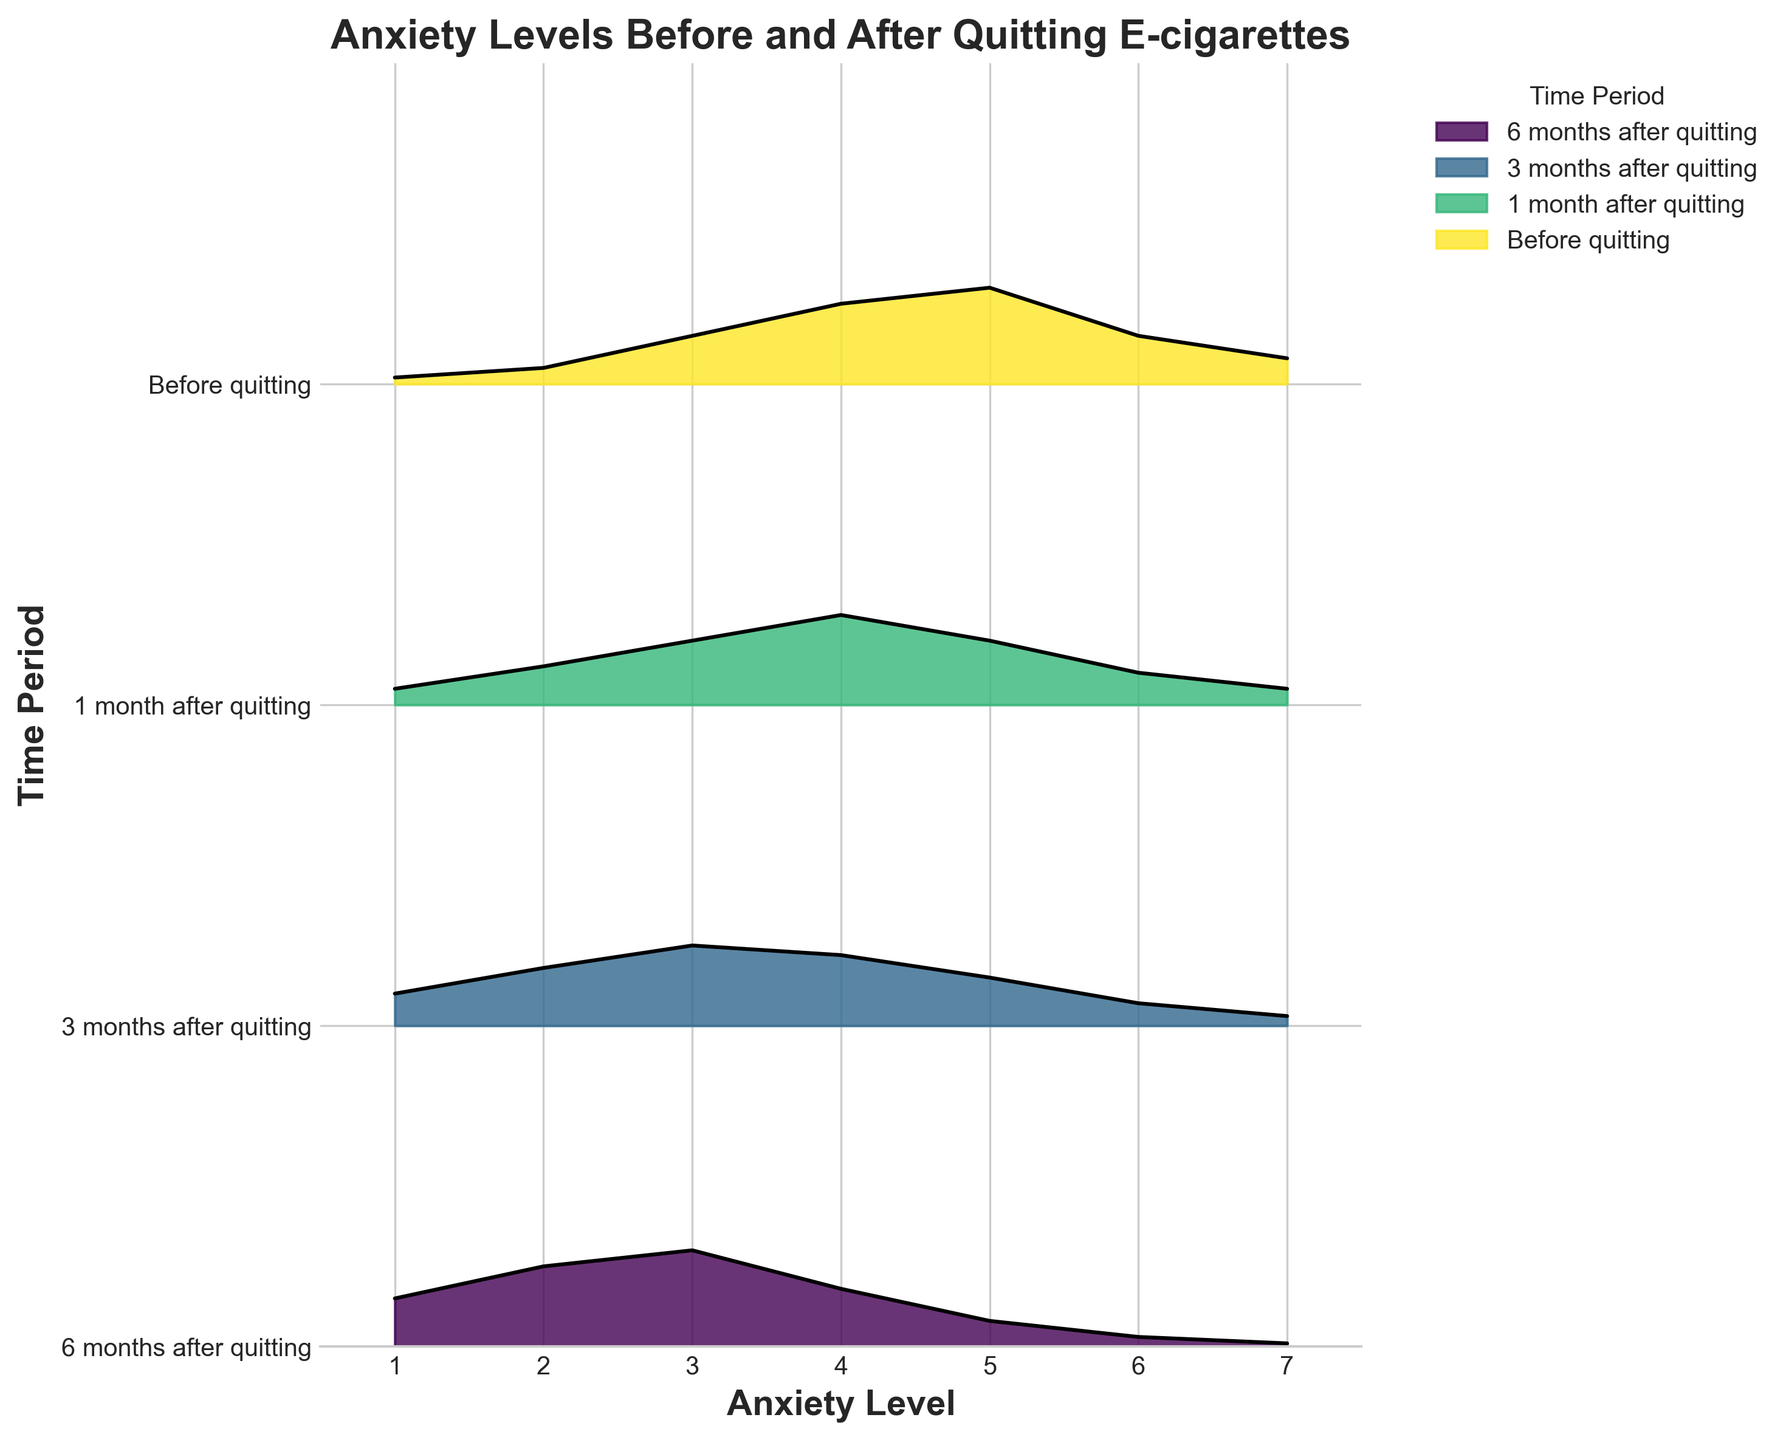What is the highest density for anxiety levels before quitting e-cigarettes? To find the highest density for anxiety levels before quitting, we look at the group "Before quitting" and identify the maximum density value, which is at anxiety level 5 with a density of 0.30.
Answer: 0.30 What anxiety level has the highest density 3 months after quitting e-cigarettes? Looking at the group "3 months after quitting," the highest density is 0.25, which corresponds to anxiety level 3.
Answer: 3 How does the peak density before quitting compare to the peak density 6 months after quitting? The peak density before quitting is 0.30 at anxiety level 5, while the peak density 6 months after quitting is 0.30 at anxiety level 3. Both peaks have the same density of 0.30.
Answer: Same What is the general trend in anxiety levels when comparing "Before quitting" and "1 month after quitting"? Before quitting, the highest density is at anxiety level 5. One month after quitting, the density is more distributed with a peak at anxiety level 4, and the distribution shifts towards lower levels of anxiety.
Answer: Anxiety decreases What is the difference in the peak density between "1 month after quitting" and "3 months after quitting"? The peak density 1 month after quitting is 0.28 at anxiety level 4, and the peak density 3 months after quitting is 0.25 at anxiety level 3. The difference is 0.28 - 0.25 = 0.03.
Answer: 0.03 What anxiety level is most common 6 months after quitting? The highest density 6 months after quitting is 0.30, which occurs at anxiety level 3.
Answer: 3 How do the distributions differ between "3 months after quitting" and "6 months after quitting" for levels 6 and 7? At 3 months after quitting, the densities for anxiety levels 6 and 7 are 0.07 and 0.03, respectively. At 6 months after quitting, the densities decrease to 0.03 for anxiety level 6 and 0.01 for anxiety level 7.
Answer: Decrease Which time period shows the most balanced distribution of anxiety levels? The most balanced or less skewed distribution appears to be during "1 month after quitting," where densities are more evenly spread across different anxiety levels.
Answer: 1 month after quitting How does the density of anxiety level 1 change from "Before quitting" to "6 months after quitting"? Before quitting, the density at anxiety level 1 is 0.02. This increases to 0.05 one month after quitting, 0.10 three months after quitting, and 0.15 six months after quitting, indicating a gradual increase.
Answer: Increases What time period shows the highest density at anxiety level 2? The group "6 months after quitting" shows the highest density at anxiety level 2, with a density of 0.25.
Answer: 6 months after quitting 